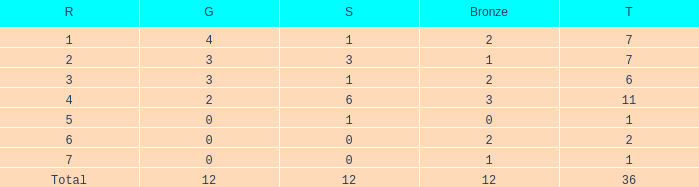What is the largest total for a team with 1 bronze, 0 gold medals and ranking of 7? None. 